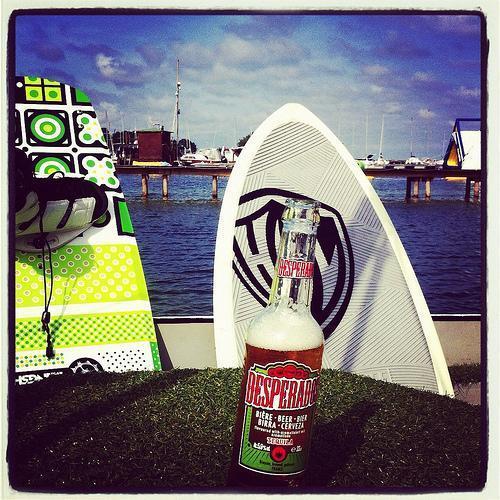How many bottles are there?
Give a very brief answer. 1. 